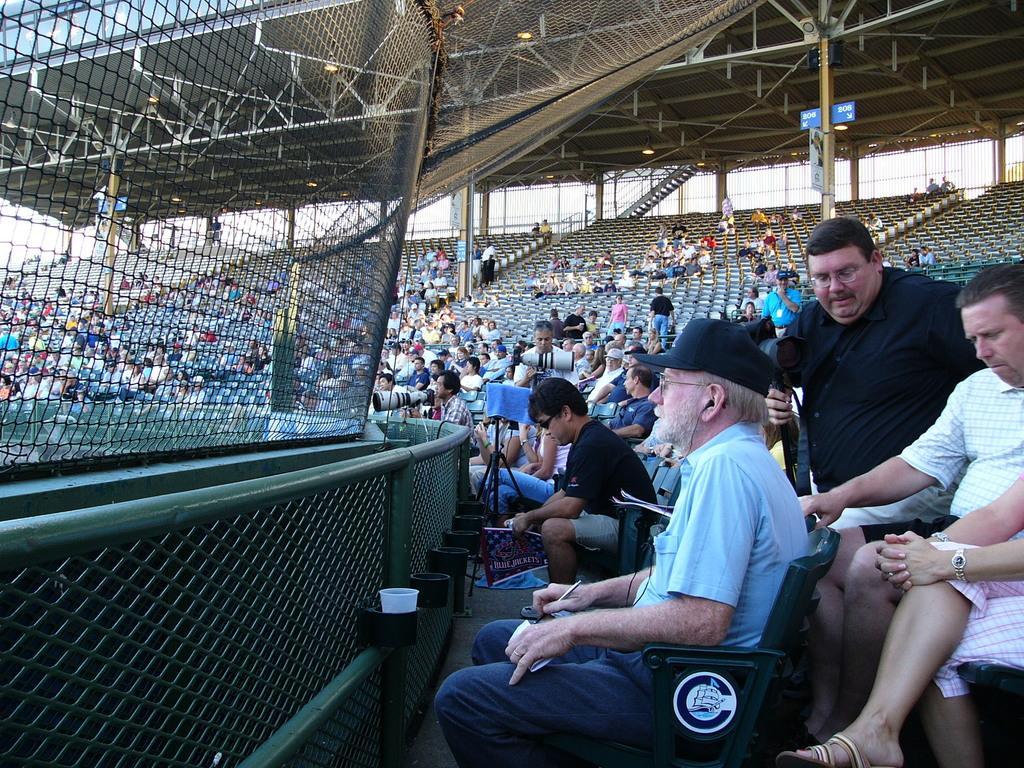In one or two sentences, can you explain what this image depicts? In this image it looks like a stadium and there are people sitting on the chairs and holding objects. We can see the stand with a camera. There are rods, fence, boards, stairs, shed and sky. 